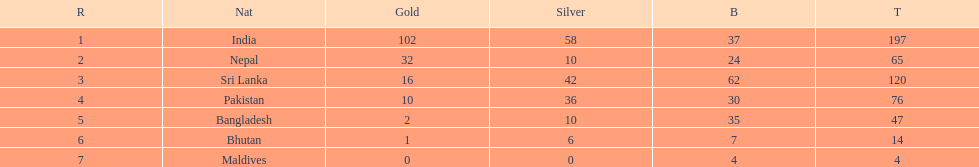Which nation has earned the least amount of gold medals? Maldives. 